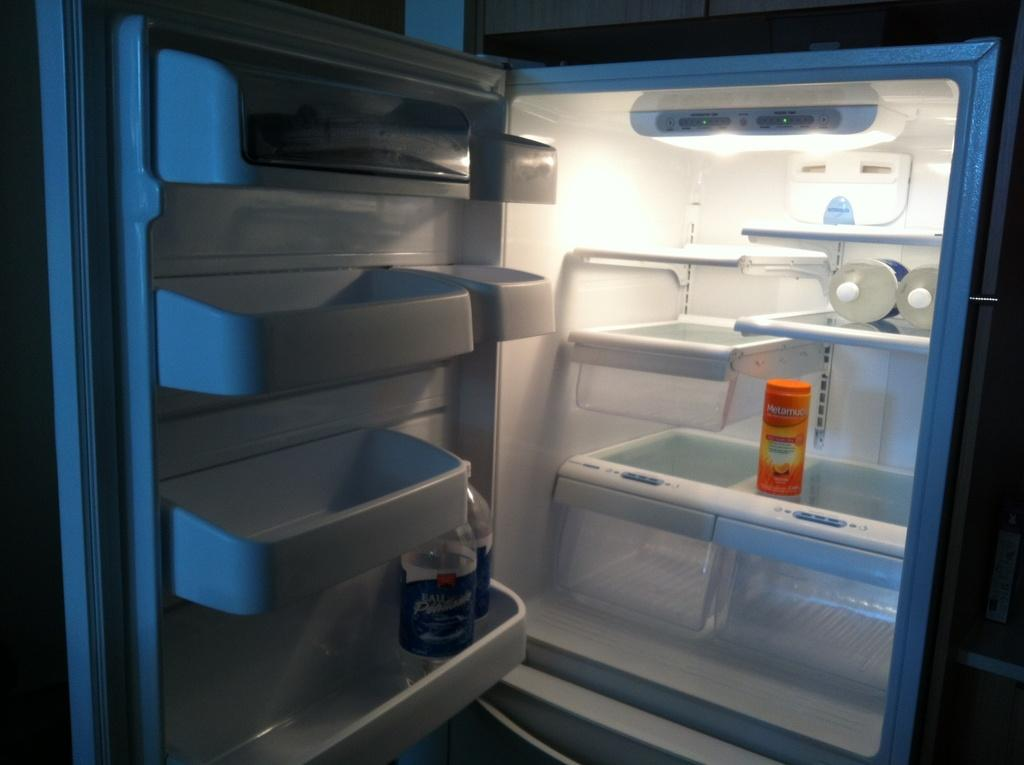<image>
Summarize the visual content of the image. An open refrigerator with barely anything in it except a container of Metamucil. 